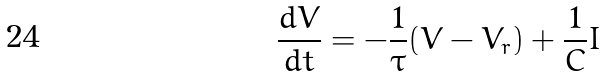<formula> <loc_0><loc_0><loc_500><loc_500>\frac { d V } { d t } = - \frac { 1 } { \tau } ( V - V _ { r } ) + \frac { 1 } { C } I</formula> 